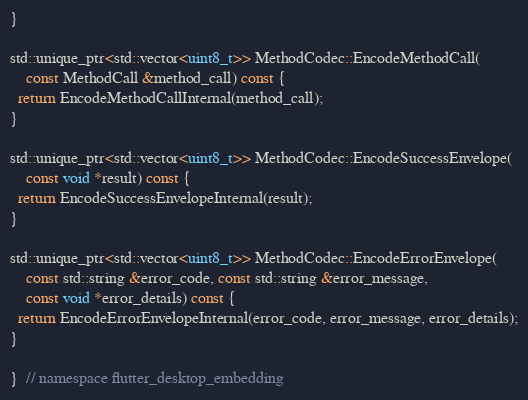<code> <loc_0><loc_0><loc_500><loc_500><_C++_>}

std::unique_ptr<std::vector<uint8_t>> MethodCodec::EncodeMethodCall(
    const MethodCall &method_call) const {
  return EncodeMethodCallInternal(method_call);
}

std::unique_ptr<std::vector<uint8_t>> MethodCodec::EncodeSuccessEnvelope(
    const void *result) const {
  return EncodeSuccessEnvelopeInternal(result);
}

std::unique_ptr<std::vector<uint8_t>> MethodCodec::EncodeErrorEnvelope(
    const std::string &error_code, const std::string &error_message,
    const void *error_details) const {
  return EncodeErrorEnvelopeInternal(error_code, error_message, error_details);
}

}  // namespace flutter_desktop_embedding
</code> 